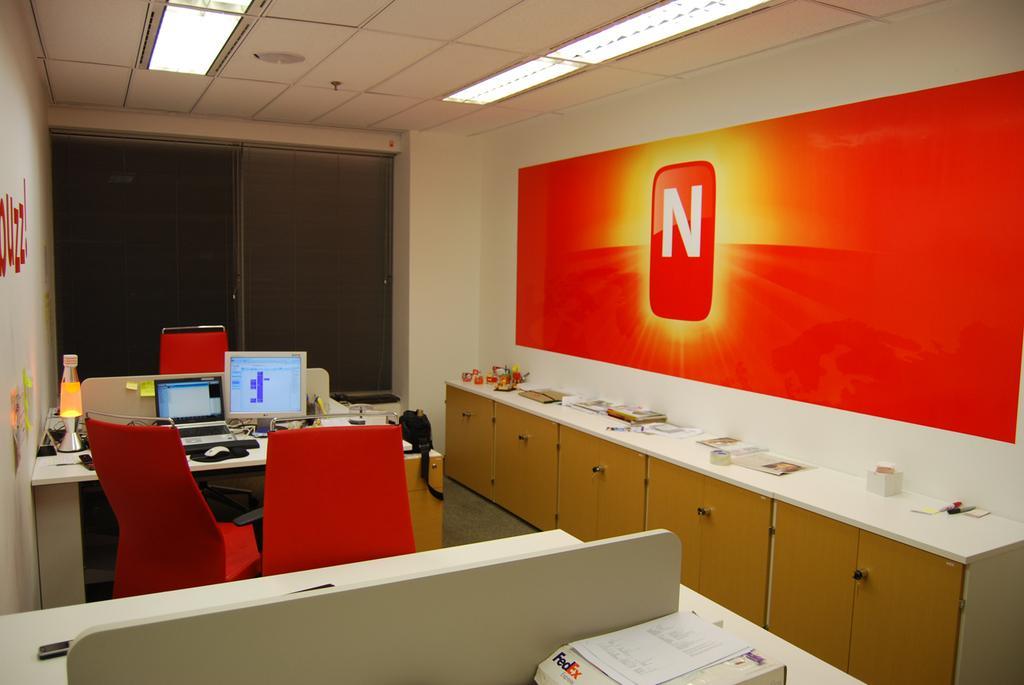In one or two sentences, can you explain what this image depicts? This is the image of a inner view of a room where we can see some tables and chairs and on the table we can see some objects like laptop, monitor, mouse and some other objects. On the right side, we can see a cupboard and there are some objects on it and we can see a wall with a poster and there is a window. 